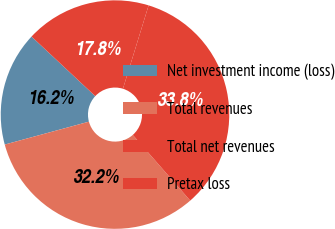Convert chart. <chart><loc_0><loc_0><loc_500><loc_500><pie_chart><fcel>Net investment income (loss)<fcel>Total revenues<fcel>Total net revenues<fcel>Pretax loss<nl><fcel>16.19%<fcel>32.21%<fcel>33.81%<fcel>17.79%<nl></chart> 